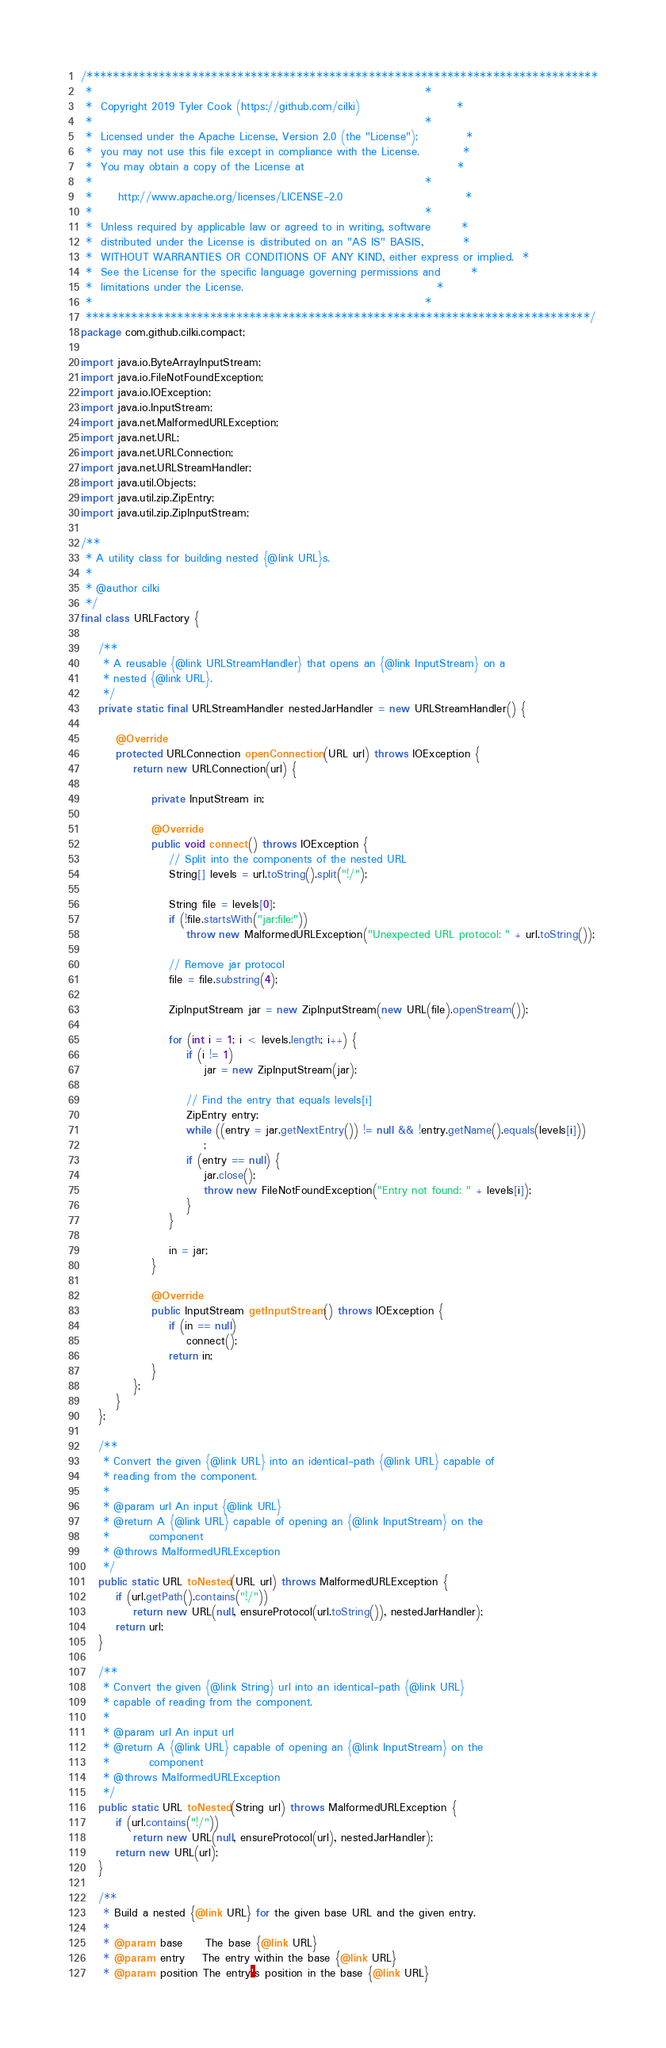<code> <loc_0><loc_0><loc_500><loc_500><_Java_>/******************************************************************************
 *                                                                            *
 *  Copyright 2019 Tyler Cook (https://github.com/cilki)                      *
 *                                                                            *
 *  Licensed under the Apache License, Version 2.0 (the "License");           *
 *  you may not use this file except in compliance with the License.          *
 *  You may obtain a copy of the License at                                   *
 *                                                                            *
 *      http://www.apache.org/licenses/LICENSE-2.0                            *
 *                                                                            *
 *  Unless required by applicable law or agreed to in writing, software       *
 *  distributed under the License is distributed on an "AS IS" BASIS,         *
 *  WITHOUT WARRANTIES OR CONDITIONS OF ANY KIND, either express or implied.  *
 *  See the License for the specific language governing permissions and       *
 *  limitations under the License.                                            *
 *                                                                            *
 *****************************************************************************/
package com.github.cilki.compact;

import java.io.ByteArrayInputStream;
import java.io.FileNotFoundException;
import java.io.IOException;
import java.io.InputStream;
import java.net.MalformedURLException;
import java.net.URL;
import java.net.URLConnection;
import java.net.URLStreamHandler;
import java.util.Objects;
import java.util.zip.ZipEntry;
import java.util.zip.ZipInputStream;

/**
 * A utility class for building nested {@link URL}s.
 * 
 * @author cilki
 */
final class URLFactory {

	/**
	 * A reusable {@link URLStreamHandler} that opens an {@link InputStream} on a
	 * nested {@link URL}.
	 */
	private static final URLStreamHandler nestedJarHandler = new URLStreamHandler() {

		@Override
		protected URLConnection openConnection(URL url) throws IOException {
			return new URLConnection(url) {

				private InputStream in;

				@Override
				public void connect() throws IOException {
					// Split into the components of the nested URL
					String[] levels = url.toString().split("!/");

					String file = levels[0];
					if (!file.startsWith("jar:file:"))
						throw new MalformedURLException("Unexpected URL protocol: " + url.toString());

					// Remove jar protocol
					file = file.substring(4);

					ZipInputStream jar = new ZipInputStream(new URL(file).openStream());

					for (int i = 1; i < levels.length; i++) {
						if (i != 1)
							jar = new ZipInputStream(jar);

						// Find the entry that equals levels[i]
						ZipEntry entry;
						while ((entry = jar.getNextEntry()) != null && !entry.getName().equals(levels[i]))
							;
						if (entry == null) {
							jar.close();
							throw new FileNotFoundException("Entry not found: " + levels[i]);
						}
					}

					in = jar;
				}

				@Override
				public InputStream getInputStream() throws IOException {
					if (in == null)
						connect();
					return in;
				}
			};
		}
	};

	/**
	 * Convert the given {@link URL} into an identical-path {@link URL} capable of
	 * reading from the component.
	 * 
	 * @param url An input {@link URL}
	 * @return A {@link URL} capable of opening an {@link InputStream} on the
	 *         component
	 * @throws MalformedURLException
	 */
	public static URL toNested(URL url) throws MalformedURLException {
		if (url.getPath().contains("!/"))
			return new URL(null, ensureProtocol(url.toString()), nestedJarHandler);
		return url;
	}

	/**
	 * Convert the given {@link String} url into an identical-path {@link URL}
	 * capable of reading from the component.
	 * 
	 * @param url An input url
	 * @return A {@link URL} capable of opening an {@link InputStream} on the
	 *         component
	 * @throws MalformedURLException
	 */
	public static URL toNested(String url) throws MalformedURLException {
		if (url.contains("!/"))
			return new URL(null, ensureProtocol(url), nestedJarHandler);
		return new URL(url);
	}

	/**
	 * Build a nested {@link URL} for the given base URL and the given entry.
	 * 
	 * @param base     The base {@link URL}
	 * @param entry    The entry within the base {@link URL}
	 * @param position The entry's position in the base {@link URL}</code> 